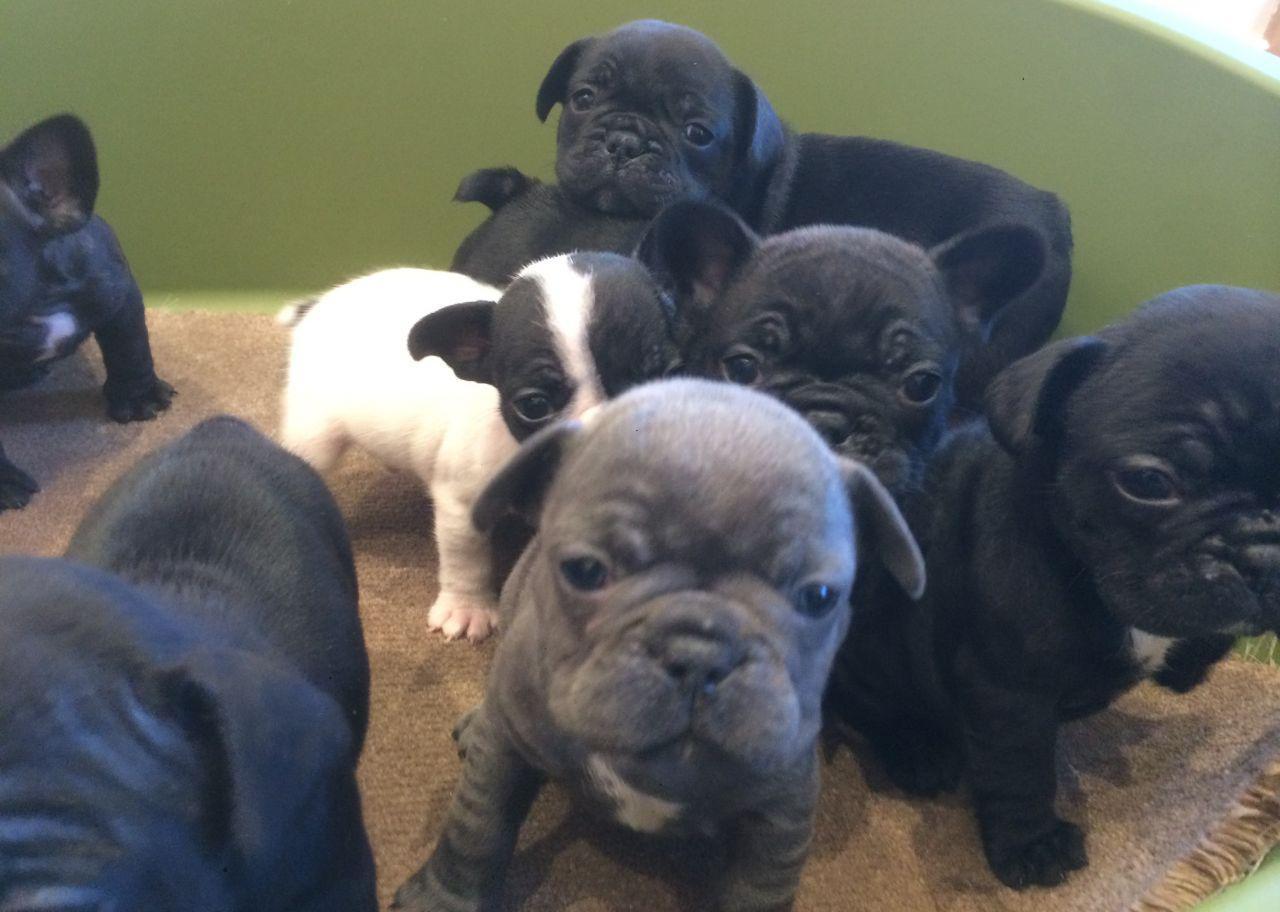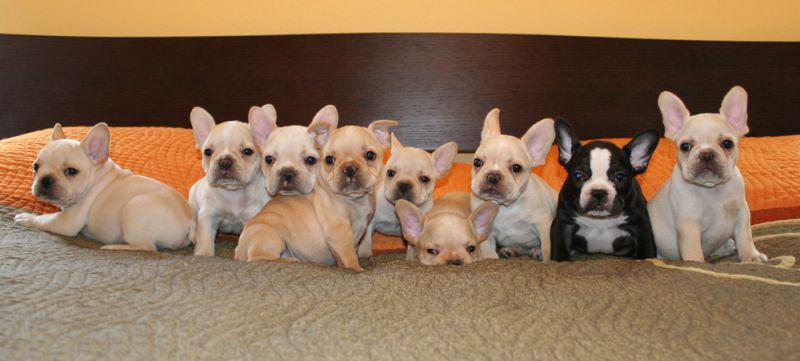The first image is the image on the left, the second image is the image on the right. Evaluate the accuracy of this statement regarding the images: "There are no more than five dogs in the right image.". Is it true? Answer yes or no. No. The first image is the image on the left, the second image is the image on the right. Given the left and right images, does the statement "There are at least five white and tan puppies along side a single black and white dog." hold true? Answer yes or no. Yes. 